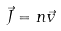Convert formula to latex. <formula><loc_0><loc_0><loc_500><loc_500>\vec { J } = n \vec { v }</formula> 